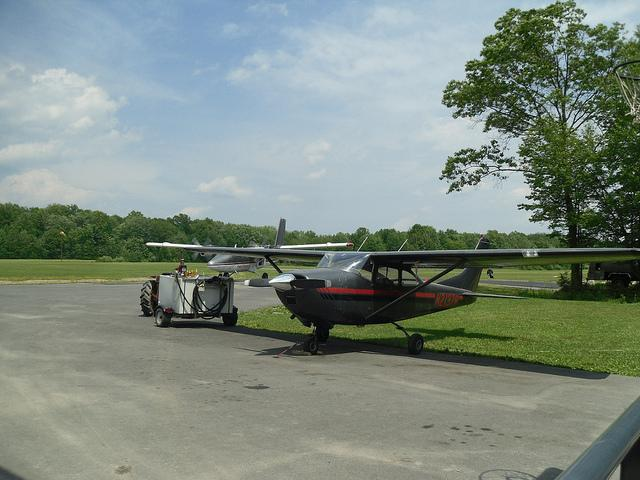What kind of transportation is shown? airplane 